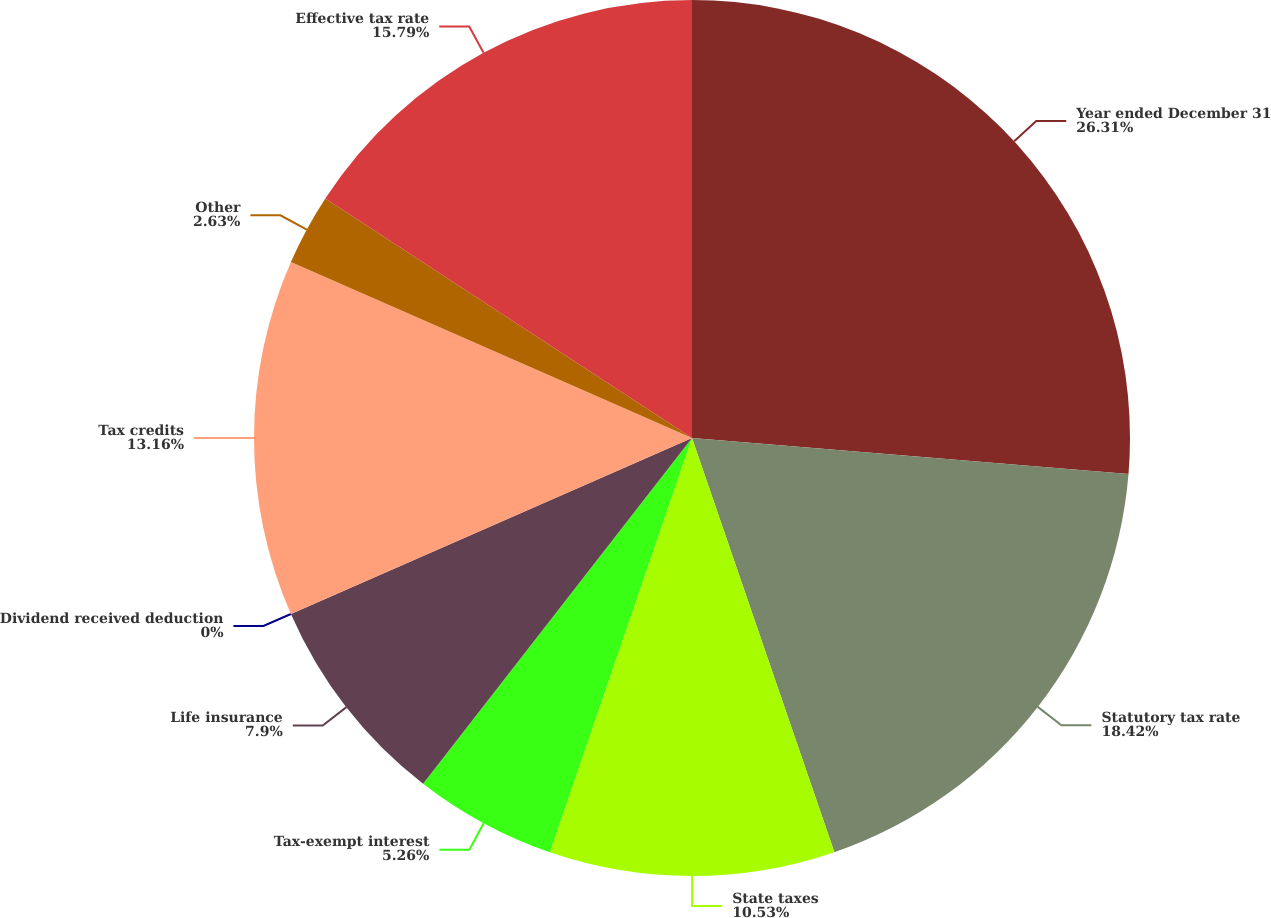Convert chart to OTSL. <chart><loc_0><loc_0><loc_500><loc_500><pie_chart><fcel>Year ended December 31<fcel>Statutory tax rate<fcel>State taxes<fcel>Tax-exempt interest<fcel>Life insurance<fcel>Dividend received deduction<fcel>Tax credits<fcel>Other<fcel>Effective tax rate<nl><fcel>26.31%<fcel>18.42%<fcel>10.53%<fcel>5.26%<fcel>7.9%<fcel>0.0%<fcel>13.16%<fcel>2.63%<fcel>15.79%<nl></chart> 